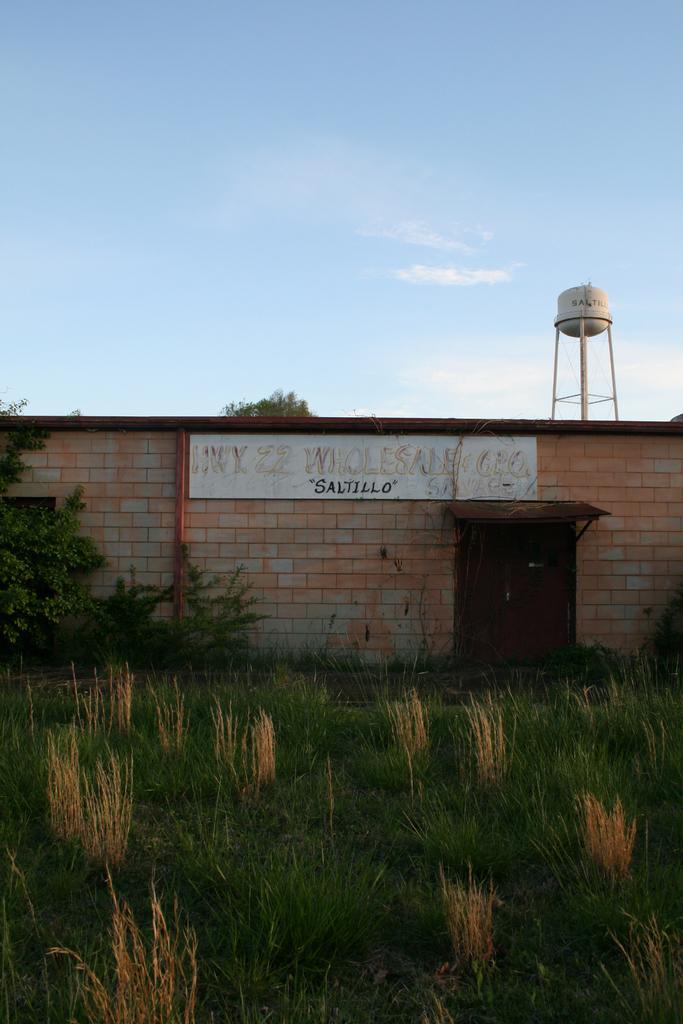In one or two sentences, can you explain what this image depicts? At the bottom of the image there is grass. In the background of the image there is wall. There is door. There is a water tank. At the top of the image there is sky. 